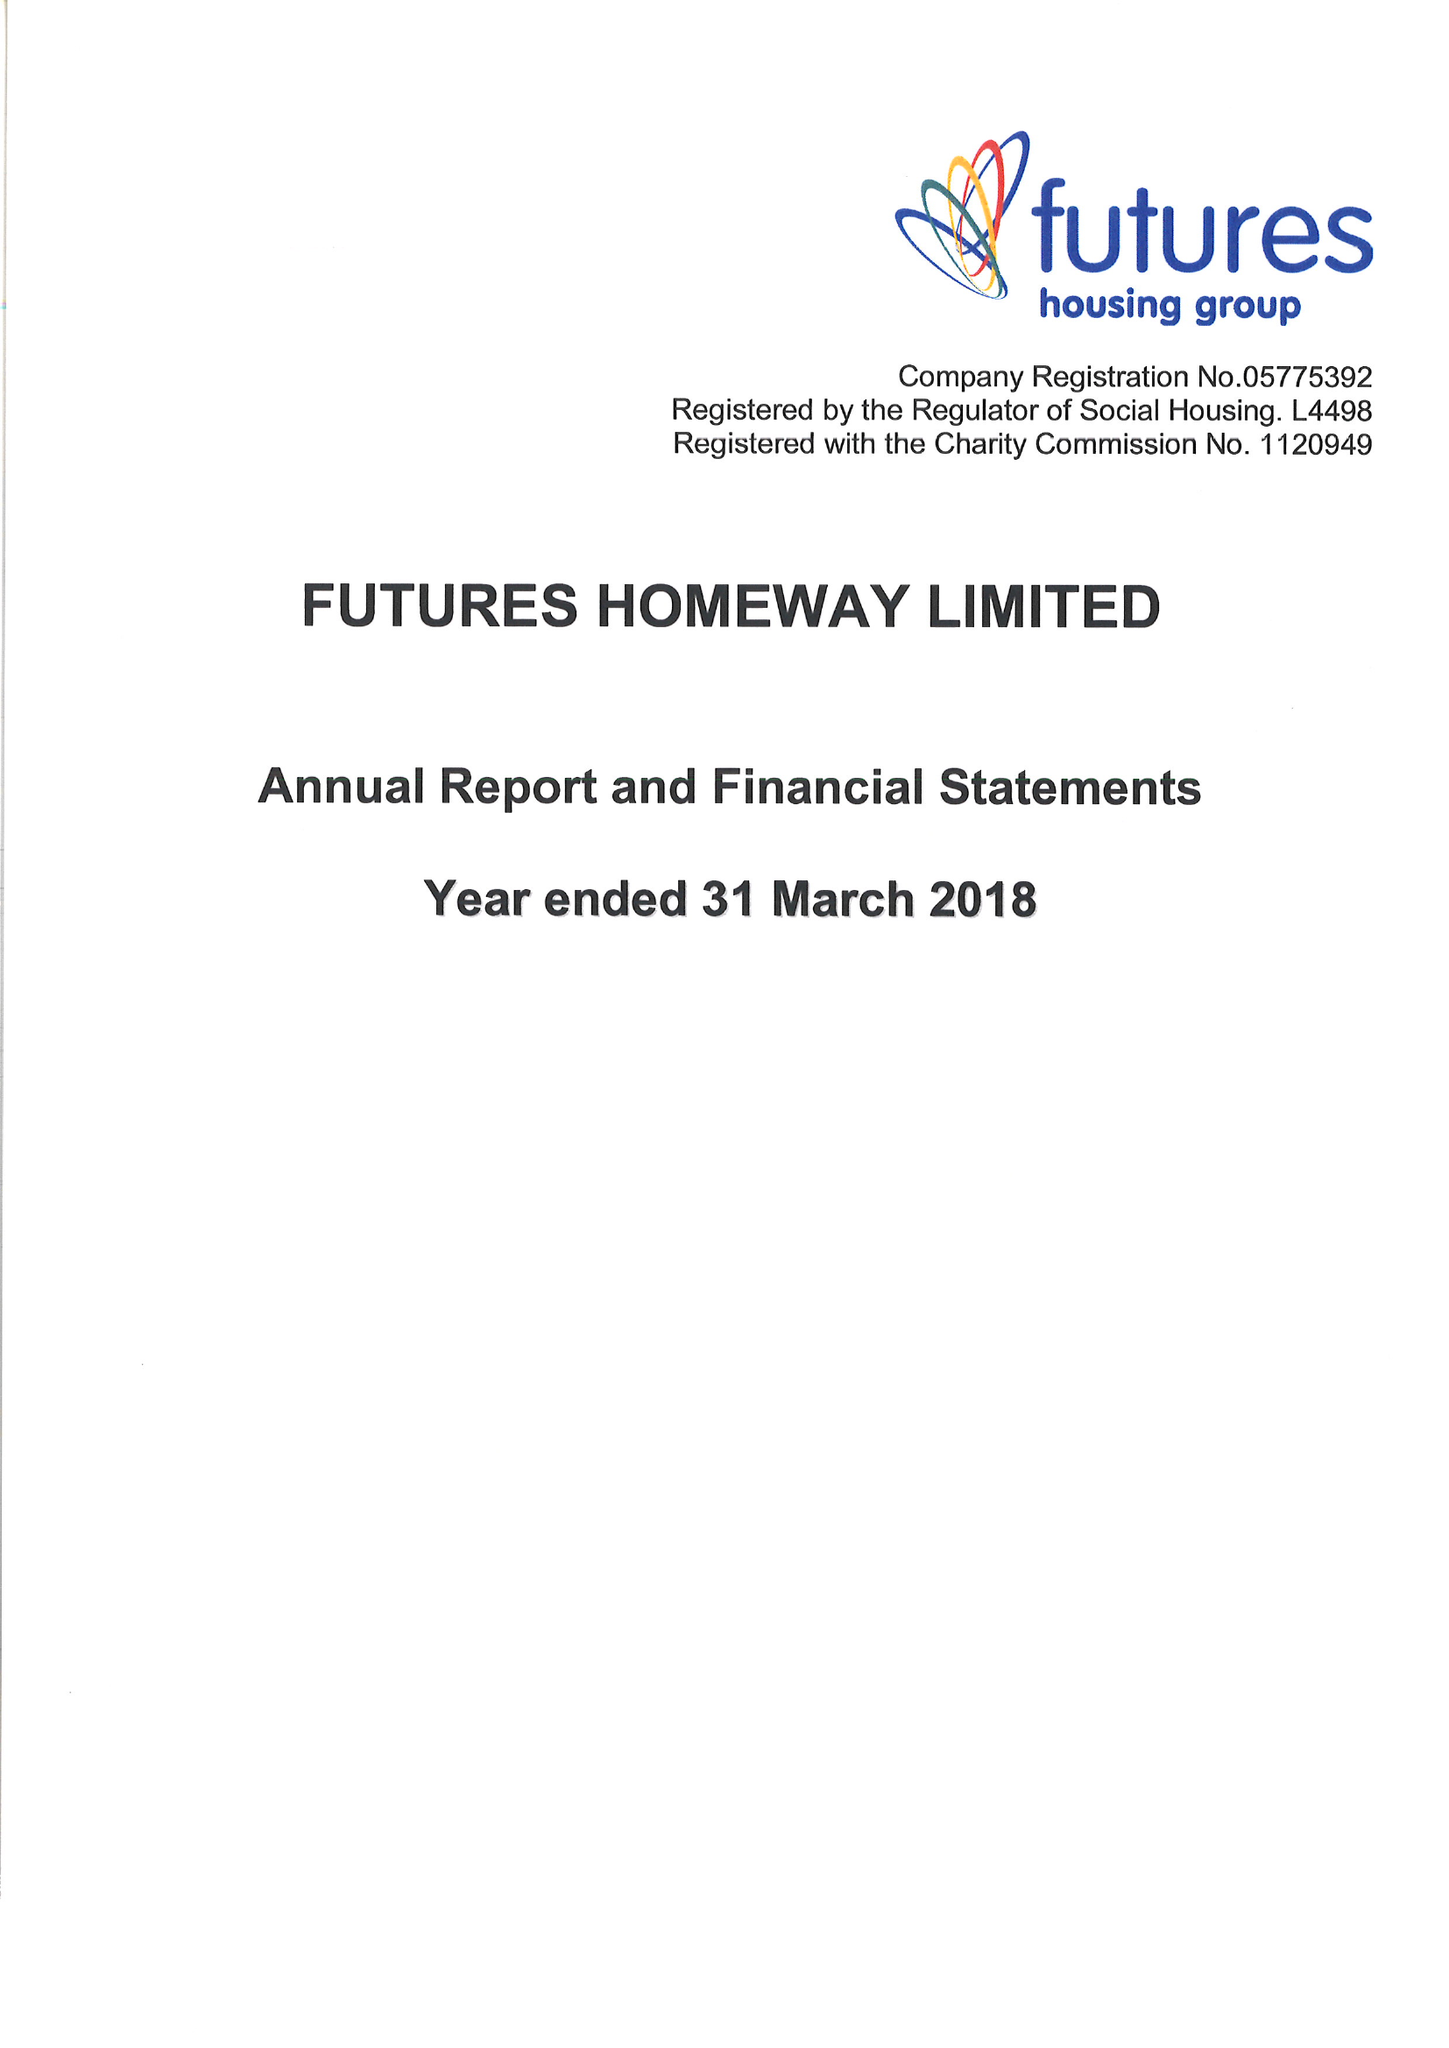What is the value for the charity_number?
Answer the question using a single word or phrase. 1120949 